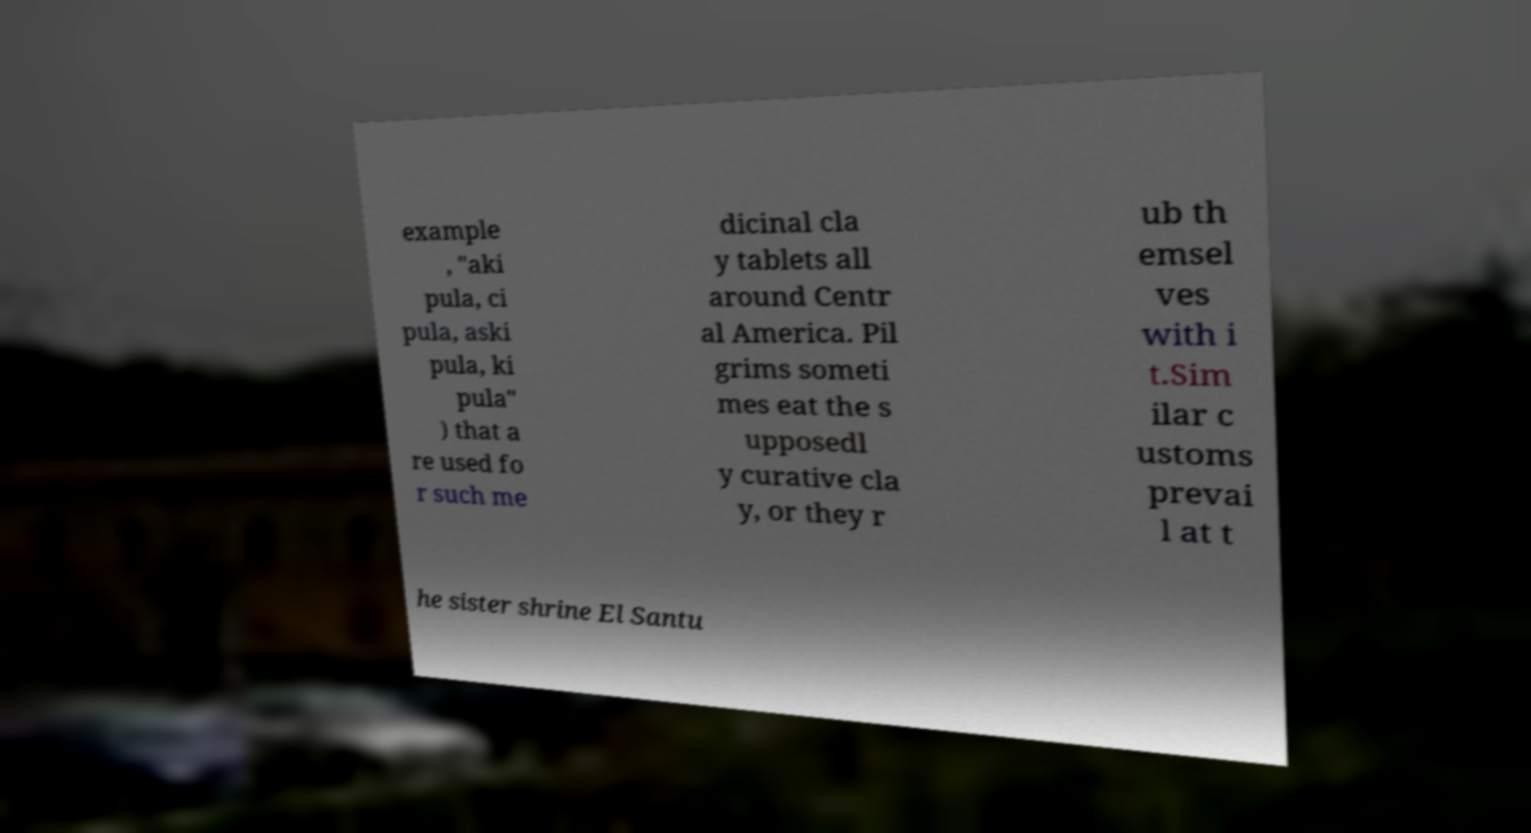For documentation purposes, I need the text within this image transcribed. Could you provide that? example , "aki pula, ci pula, aski pula, ki pula" ) that a re used fo r such me dicinal cla y tablets all around Centr al America. Pil grims someti mes eat the s upposedl y curative cla y, or they r ub th emsel ves with i t.Sim ilar c ustoms prevai l at t he sister shrine El Santu 